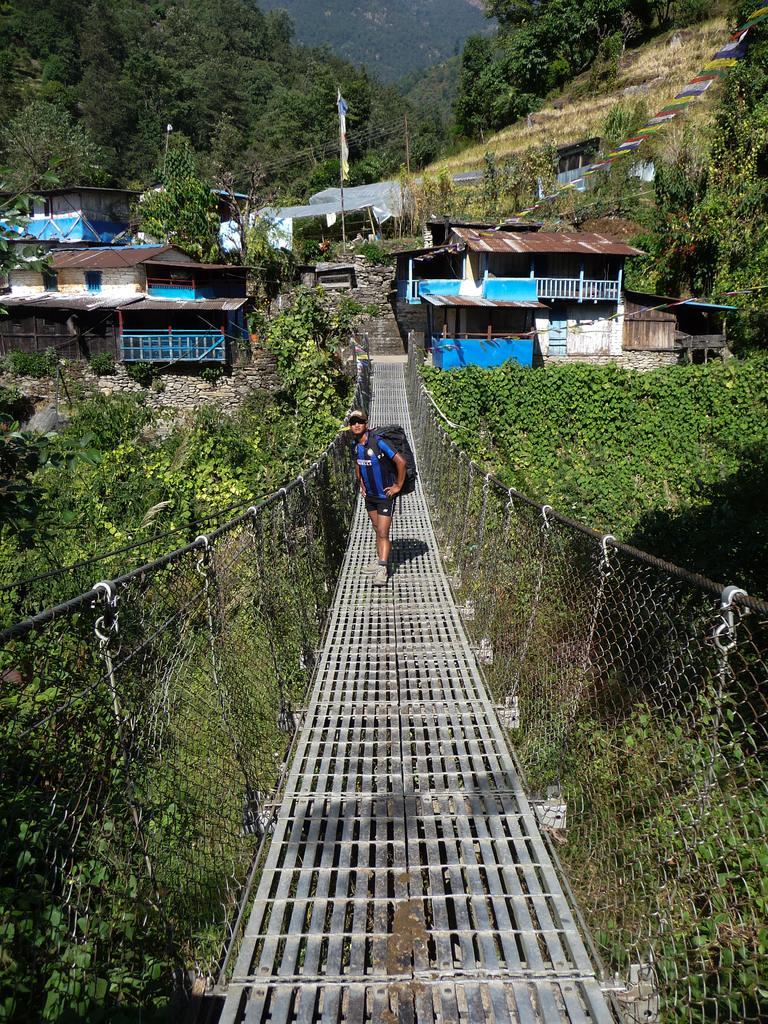In one or two sentences, can you explain what this image depicts? In the middle of this image, there is a bridge having fences on both sides and there is a person standing on this bridge. In the background, there are buildings having roofs, there are trees, plants and a mountain. 